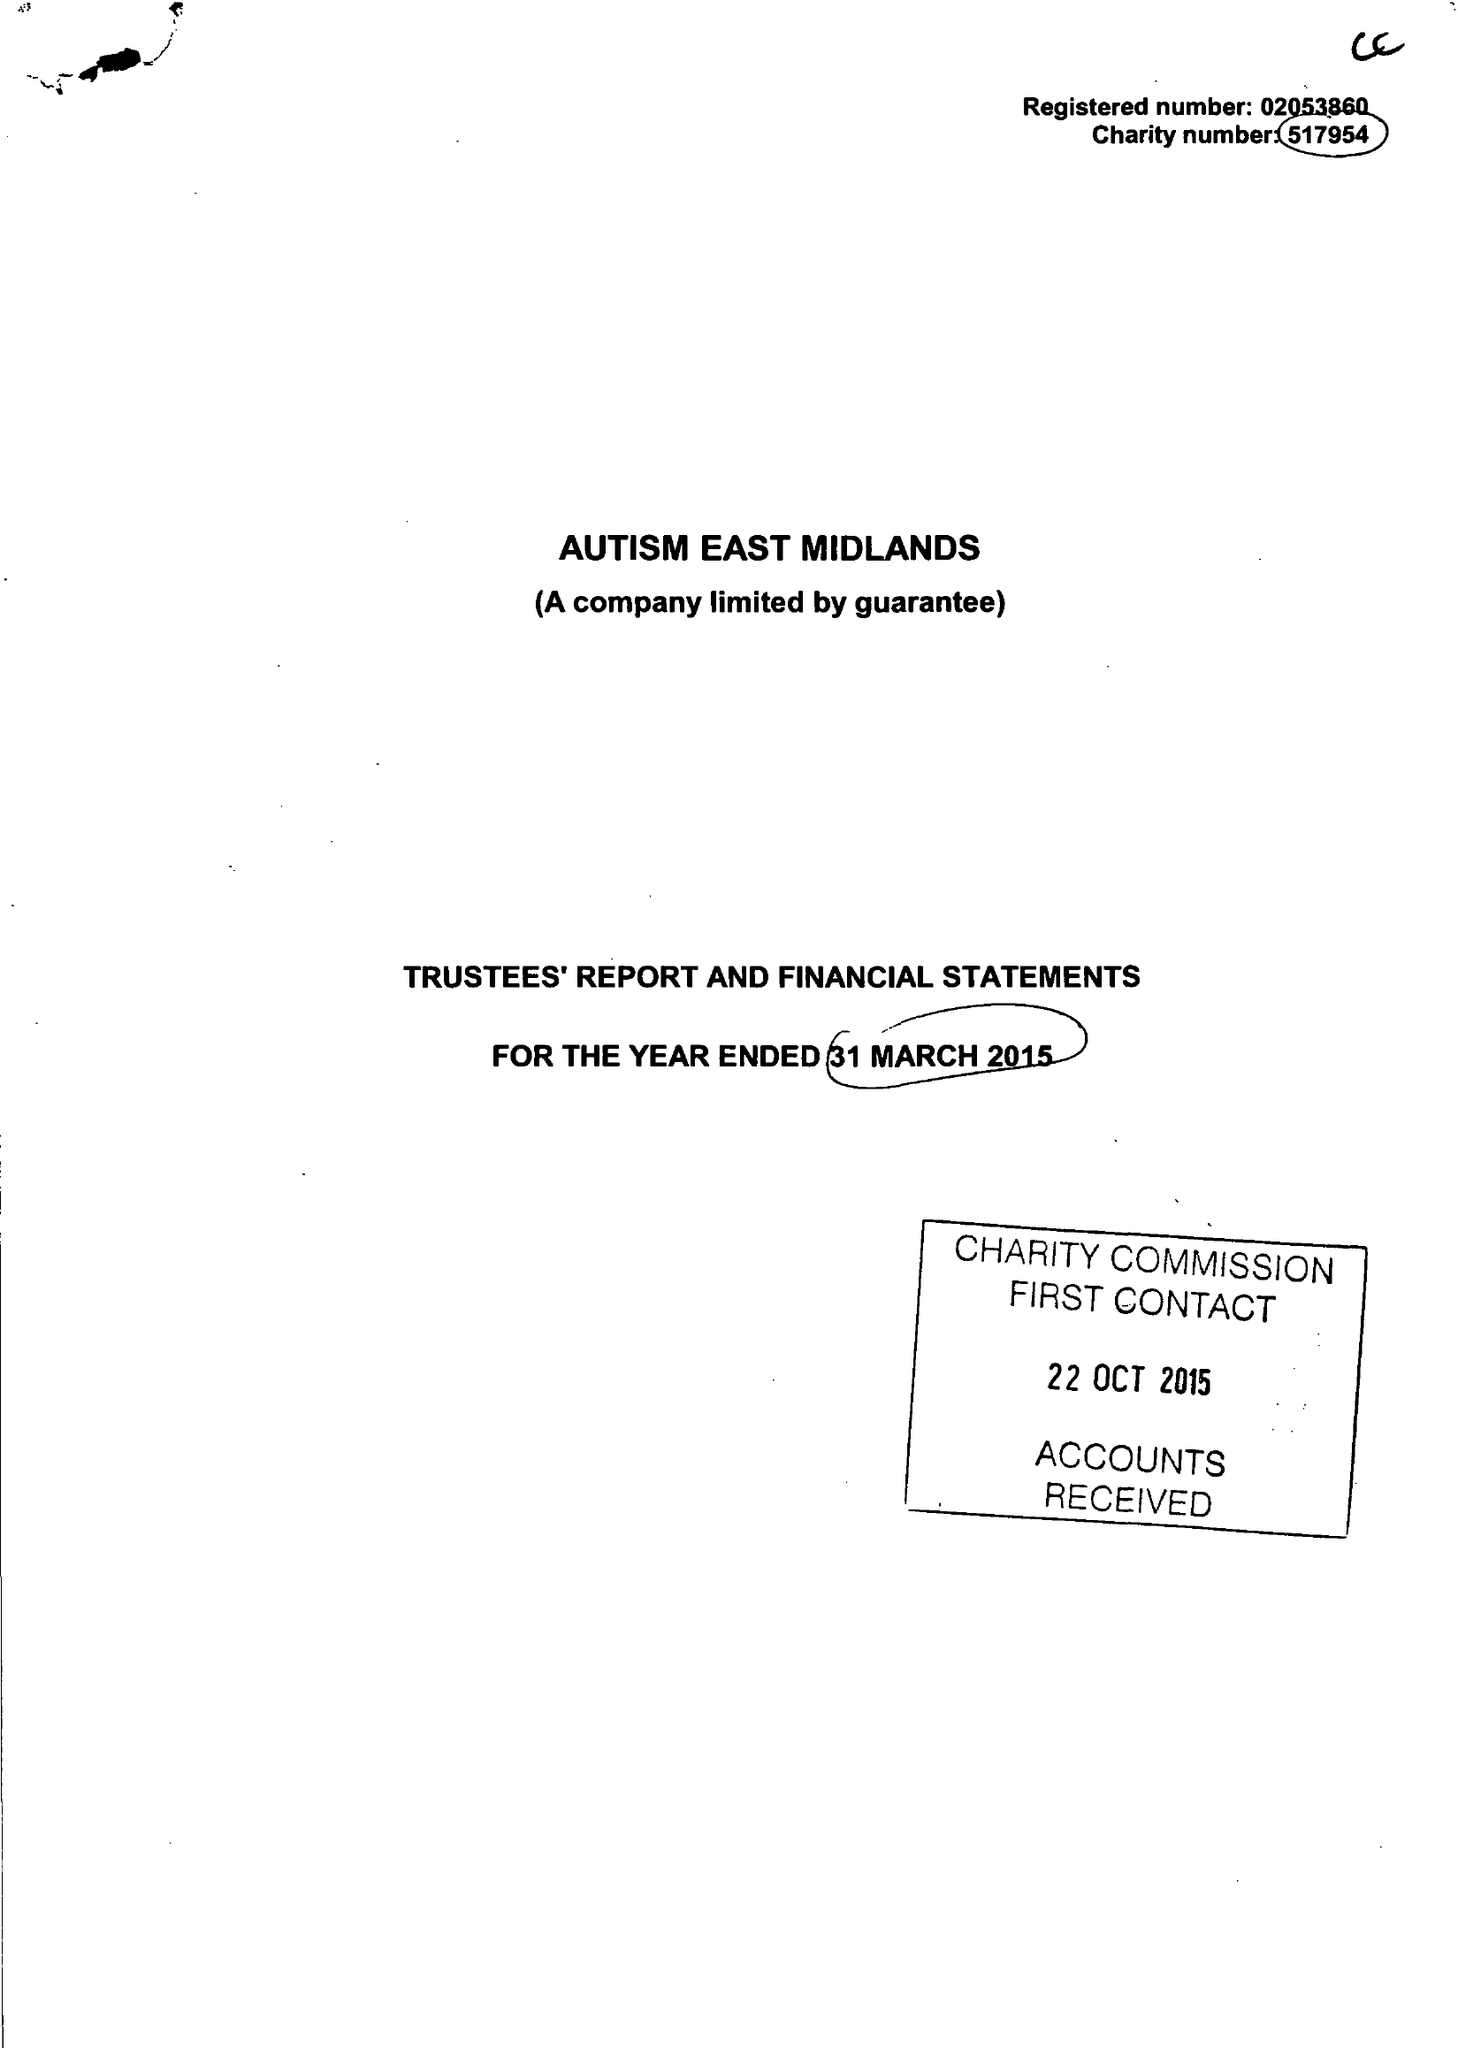What is the value for the address__postcode?
Answer the question using a single word or phrase. S80 4AJ 